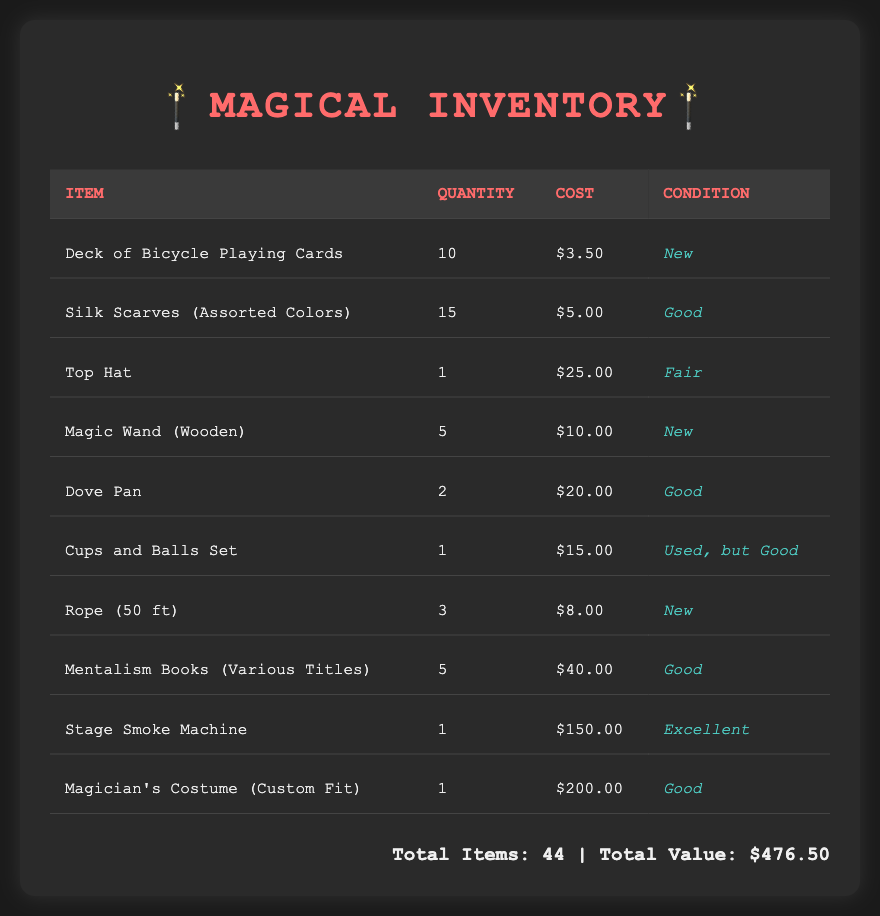What is the quantity of Deck of Bicycle Playing Cards? The quantity of Deck of Bicycle Playing Cards is specified in the document under the quantity column.
Answer: 10 What is the cost of the Stage Smoke Machine? The cost of the Stage Smoke Machine is indicated in the cost column of the document.
Answer: $150.00 How many items are in total? The total number of items is summarized at the bottom of the document.
Answer: 44 What is the condition of the Magic Wand (Wooden)? The condition of the Magic Wand (Wooden) is listed in the condition column of the document.
Answer: New Which item has the highest cost? The item with the highest cost can be determined by comparing the costs listed for each item in the document.
Answer: Magician's Costume (Custom Fit) 